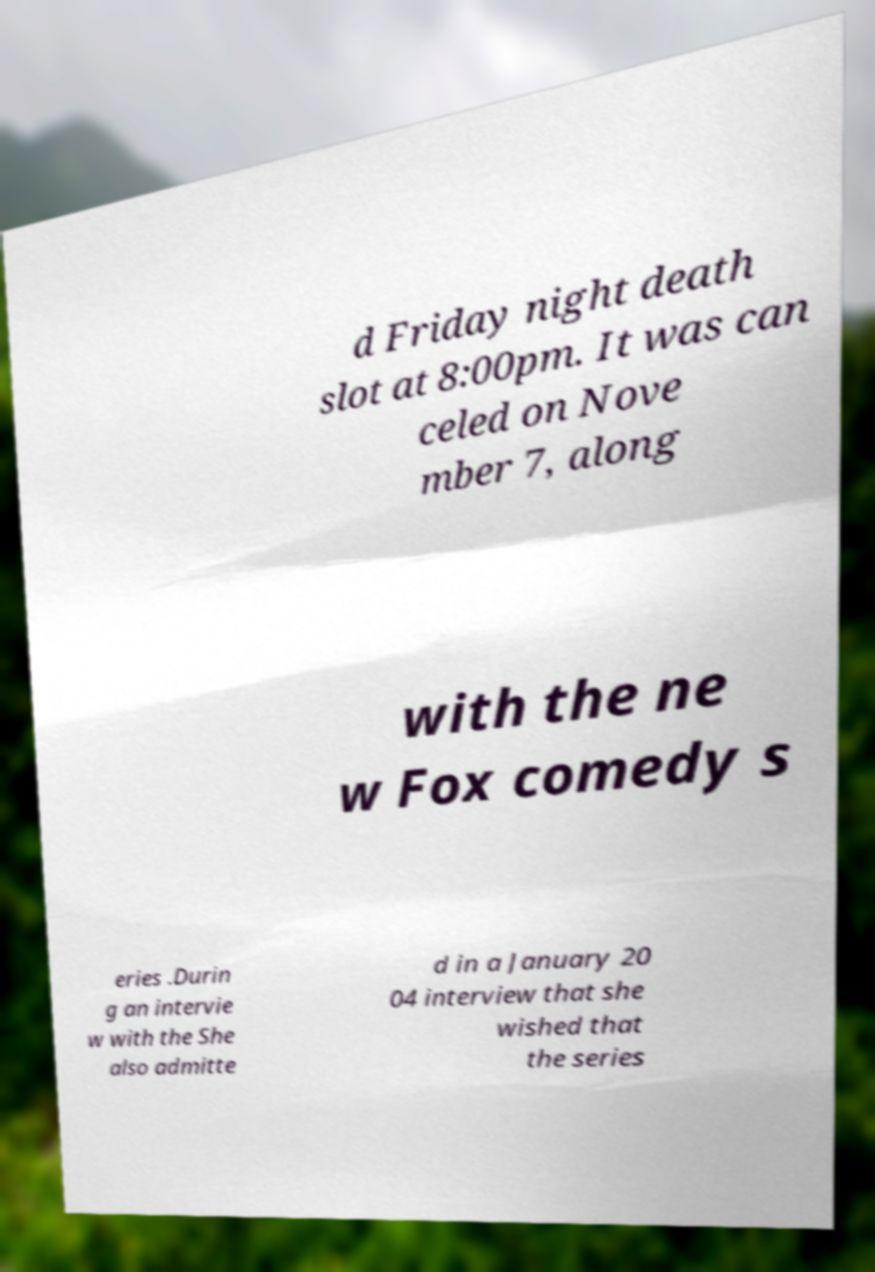Could you assist in decoding the text presented in this image and type it out clearly? d Friday night death slot at 8:00pm. It was can celed on Nove mber 7, along with the ne w Fox comedy s eries .Durin g an intervie w with the She also admitte d in a January 20 04 interview that she wished that the series 